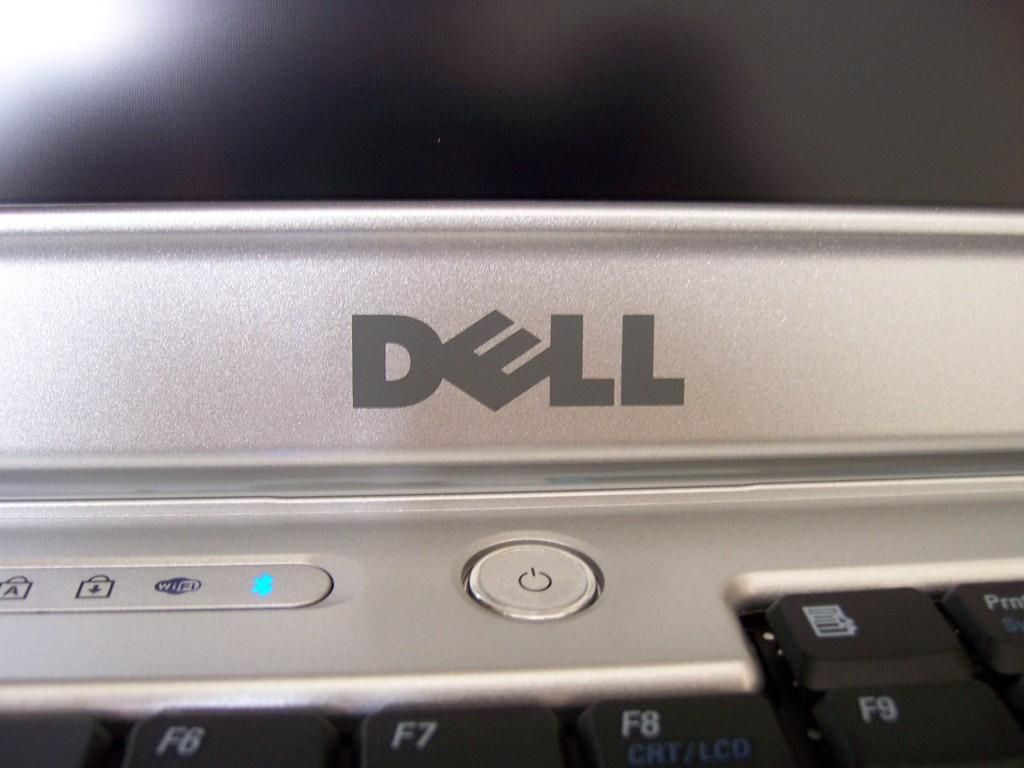What type of electronic device is visible in the image? There is a dell laptop in the image. Can you describe the laptop's brand or model? The laptop is a dell laptop. What type of dinosaurs can be seen interacting with the laptop in the image? There are no dinosaurs present in the image; it features a dell laptop. What type of skin is visible on the laptop in the image? The laptop is an electronic device and does not have skin. 